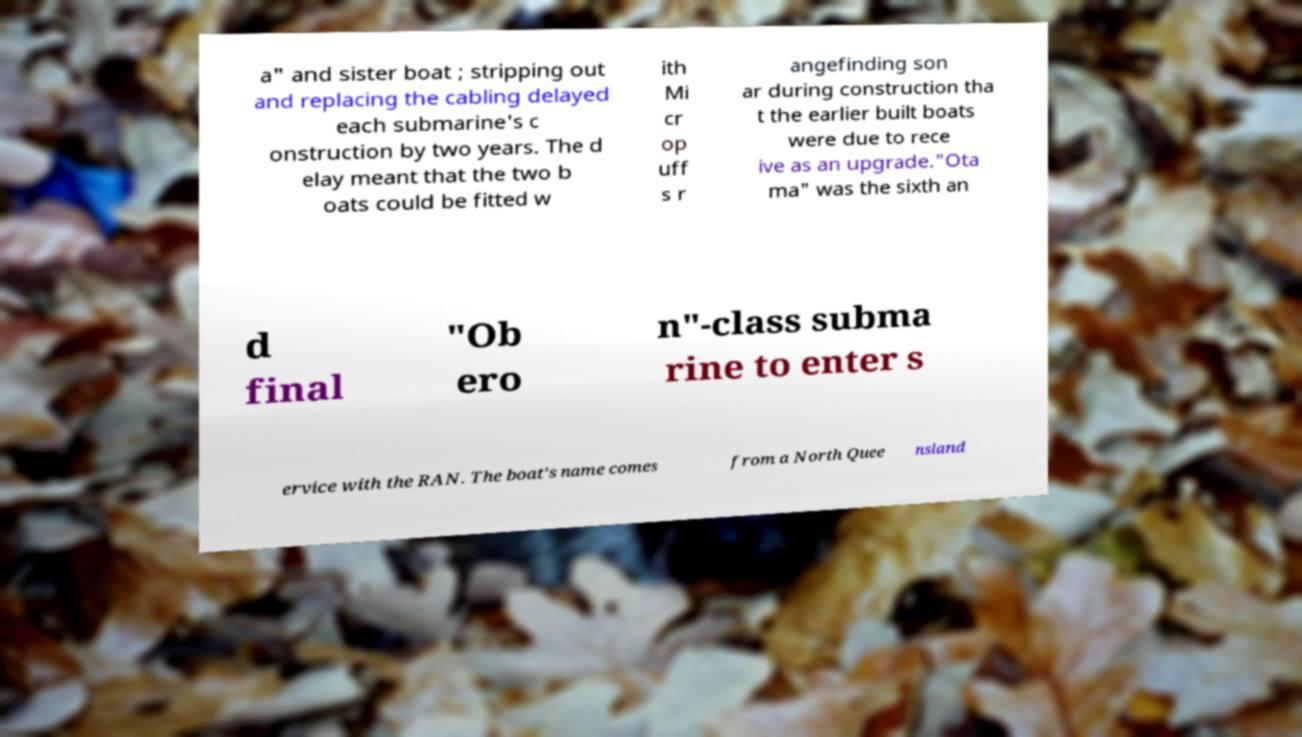Can you read and provide the text displayed in the image?This photo seems to have some interesting text. Can you extract and type it out for me? a" and sister boat ; stripping out and replacing the cabling delayed each submarine's c onstruction by two years. The d elay meant that the two b oats could be fitted w ith Mi cr op uff s r angefinding son ar during construction tha t the earlier built boats were due to rece ive as an upgrade."Ota ma" was the sixth an d final "Ob ero n"-class subma rine to enter s ervice with the RAN. The boat's name comes from a North Quee nsland 